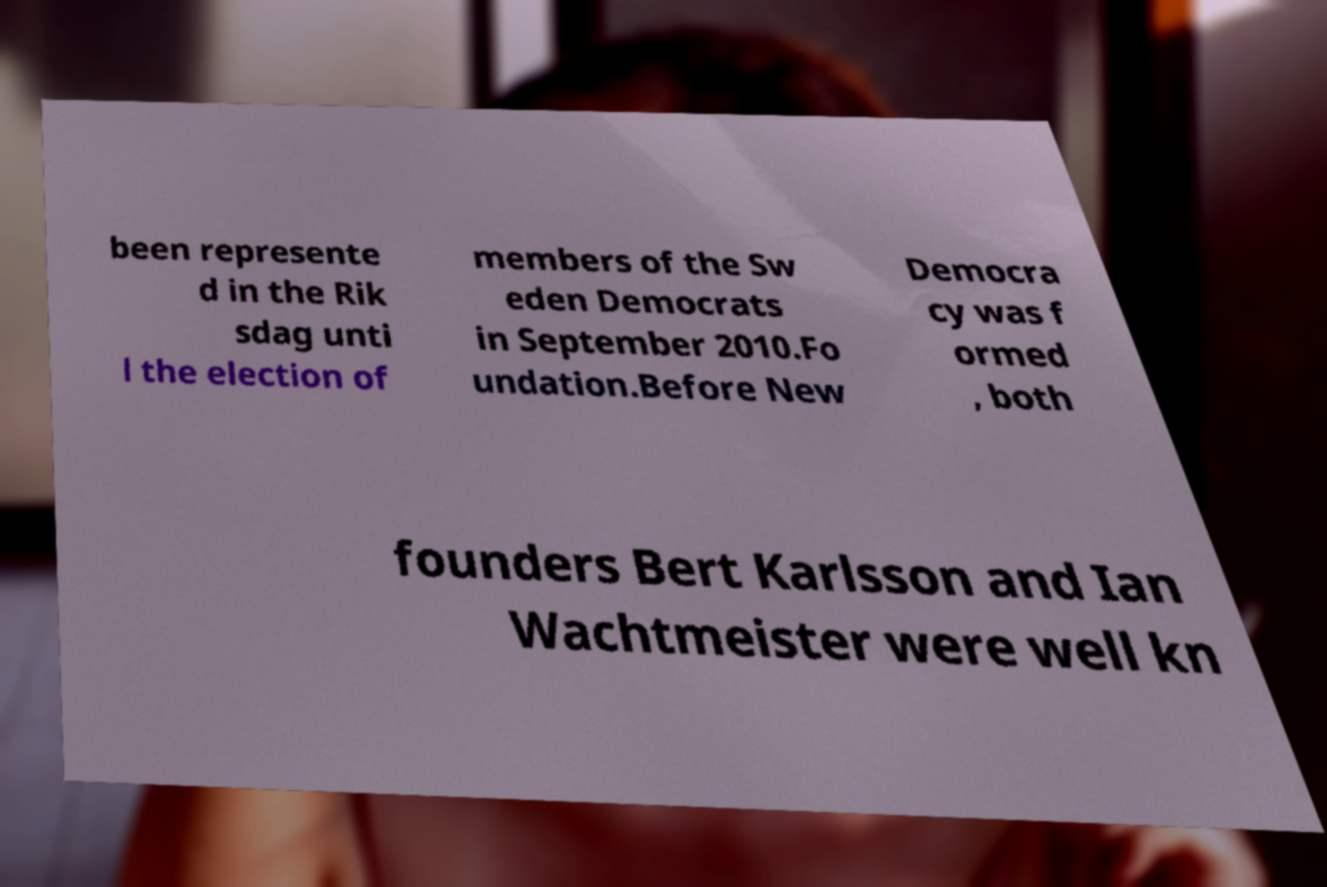What messages or text are displayed in this image? I need them in a readable, typed format. been represente d in the Rik sdag unti l the election of members of the Sw eden Democrats in September 2010.Fo undation.Before New Democra cy was f ormed , both founders Bert Karlsson and Ian Wachtmeister were well kn 